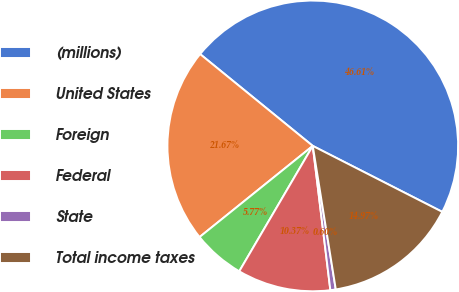<chart> <loc_0><loc_0><loc_500><loc_500><pie_chart><fcel>(millions)<fcel>United States<fcel>Foreign<fcel>Federal<fcel>State<fcel>Total income taxes<nl><fcel>46.61%<fcel>21.67%<fcel>5.77%<fcel>10.37%<fcel>0.6%<fcel>14.97%<nl></chart> 